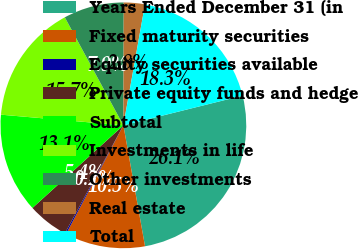Convert chart to OTSL. <chart><loc_0><loc_0><loc_500><loc_500><pie_chart><fcel>Years Ended December 31 (in<fcel>Fixed maturity securities<fcel>Equity securities available<fcel>Private equity funds and hedge<fcel>Subtotal<fcel>Investments in life<fcel>Other investments<fcel>Real estate<fcel>Total<nl><fcel>26.07%<fcel>10.54%<fcel>0.18%<fcel>5.36%<fcel>13.12%<fcel>15.71%<fcel>7.95%<fcel>2.77%<fcel>18.3%<nl></chart> 